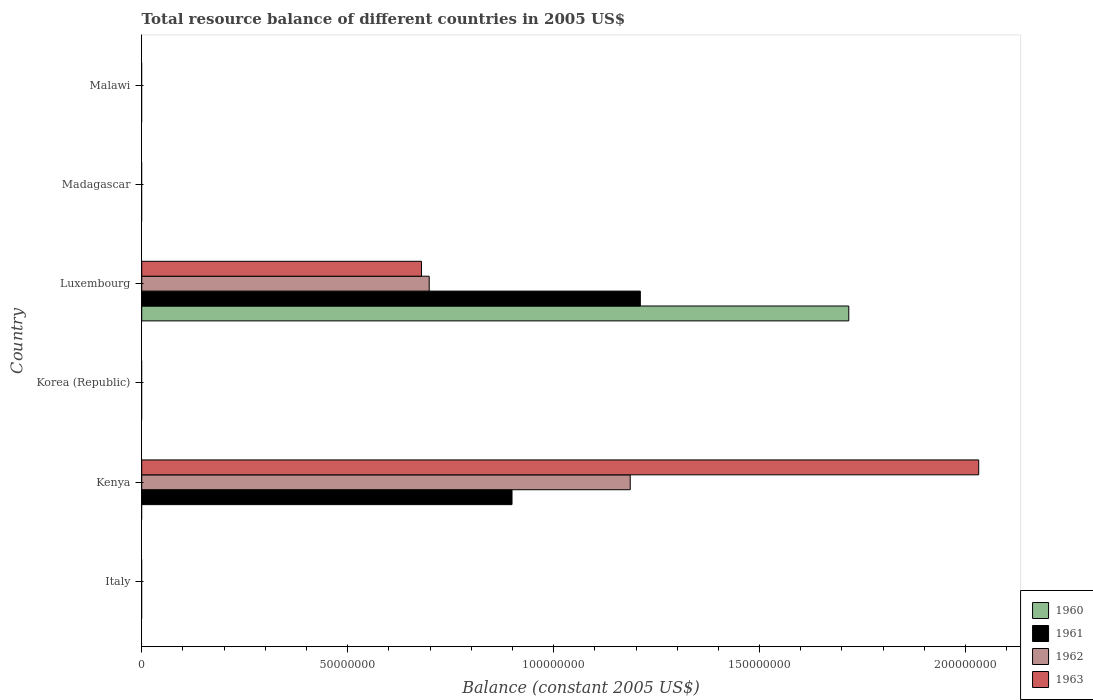Are the number of bars per tick equal to the number of legend labels?
Your answer should be very brief. No. How many bars are there on the 4th tick from the bottom?
Ensure brevity in your answer.  4. What is the total resource balance in 1962 in Korea (Republic)?
Provide a succinct answer. 0. Across all countries, what is the maximum total resource balance in 1963?
Make the answer very short. 2.03e+08. In which country was the total resource balance in 1960 maximum?
Your response must be concise. Luxembourg. What is the total total resource balance in 1963 in the graph?
Offer a terse response. 2.71e+08. What is the difference between the total resource balance in 1963 in Kenya and that in Luxembourg?
Your answer should be very brief. 1.35e+08. What is the difference between the total resource balance in 1962 in Kenya and the total resource balance in 1961 in Malawi?
Provide a succinct answer. 1.19e+08. What is the average total resource balance in 1961 per country?
Provide a succinct answer. 3.52e+07. What is the difference between the total resource balance in 1963 and total resource balance in 1960 in Luxembourg?
Keep it short and to the point. -1.04e+08. What is the difference between the highest and the lowest total resource balance in 1963?
Your answer should be very brief. 2.03e+08. Is it the case that in every country, the sum of the total resource balance in 1960 and total resource balance in 1962 is greater than the total resource balance in 1963?
Your answer should be compact. No. How many bars are there?
Offer a very short reply. 7. What is the difference between two consecutive major ticks on the X-axis?
Your response must be concise. 5.00e+07. Are the values on the major ticks of X-axis written in scientific E-notation?
Your answer should be very brief. No. Does the graph contain any zero values?
Offer a terse response. Yes. What is the title of the graph?
Provide a succinct answer. Total resource balance of different countries in 2005 US$. Does "2010" appear as one of the legend labels in the graph?
Offer a terse response. No. What is the label or title of the X-axis?
Offer a terse response. Balance (constant 2005 US$). What is the label or title of the Y-axis?
Offer a very short reply. Country. What is the Balance (constant 2005 US$) of 1960 in Italy?
Offer a very short reply. 0. What is the Balance (constant 2005 US$) in 1963 in Italy?
Make the answer very short. 0. What is the Balance (constant 2005 US$) of 1960 in Kenya?
Provide a short and direct response. 0. What is the Balance (constant 2005 US$) in 1961 in Kenya?
Offer a terse response. 8.99e+07. What is the Balance (constant 2005 US$) in 1962 in Kenya?
Offer a terse response. 1.19e+08. What is the Balance (constant 2005 US$) in 1963 in Kenya?
Offer a terse response. 2.03e+08. What is the Balance (constant 2005 US$) in 1962 in Korea (Republic)?
Ensure brevity in your answer.  0. What is the Balance (constant 2005 US$) of 1963 in Korea (Republic)?
Offer a very short reply. 0. What is the Balance (constant 2005 US$) of 1960 in Luxembourg?
Ensure brevity in your answer.  1.72e+08. What is the Balance (constant 2005 US$) in 1961 in Luxembourg?
Your answer should be compact. 1.21e+08. What is the Balance (constant 2005 US$) of 1962 in Luxembourg?
Your answer should be compact. 6.98e+07. What is the Balance (constant 2005 US$) of 1963 in Luxembourg?
Ensure brevity in your answer.  6.79e+07. What is the Balance (constant 2005 US$) in 1960 in Madagascar?
Keep it short and to the point. 0. What is the Balance (constant 2005 US$) of 1961 in Madagascar?
Your response must be concise. 0. What is the Balance (constant 2005 US$) of 1962 in Madagascar?
Offer a terse response. 0. What is the Balance (constant 2005 US$) of 1960 in Malawi?
Your answer should be very brief. 0. What is the Balance (constant 2005 US$) of 1961 in Malawi?
Offer a terse response. 0. What is the Balance (constant 2005 US$) of 1963 in Malawi?
Keep it short and to the point. 0. Across all countries, what is the maximum Balance (constant 2005 US$) in 1960?
Provide a short and direct response. 1.72e+08. Across all countries, what is the maximum Balance (constant 2005 US$) in 1961?
Offer a very short reply. 1.21e+08. Across all countries, what is the maximum Balance (constant 2005 US$) in 1962?
Offer a very short reply. 1.19e+08. Across all countries, what is the maximum Balance (constant 2005 US$) of 1963?
Make the answer very short. 2.03e+08. Across all countries, what is the minimum Balance (constant 2005 US$) in 1961?
Make the answer very short. 0. What is the total Balance (constant 2005 US$) in 1960 in the graph?
Offer a very short reply. 1.72e+08. What is the total Balance (constant 2005 US$) of 1961 in the graph?
Your response must be concise. 2.11e+08. What is the total Balance (constant 2005 US$) of 1962 in the graph?
Ensure brevity in your answer.  1.88e+08. What is the total Balance (constant 2005 US$) in 1963 in the graph?
Make the answer very short. 2.71e+08. What is the difference between the Balance (constant 2005 US$) of 1961 in Kenya and that in Luxembourg?
Provide a succinct answer. -3.11e+07. What is the difference between the Balance (constant 2005 US$) of 1962 in Kenya and that in Luxembourg?
Make the answer very short. 4.88e+07. What is the difference between the Balance (constant 2005 US$) in 1963 in Kenya and that in Luxembourg?
Provide a succinct answer. 1.35e+08. What is the difference between the Balance (constant 2005 US$) in 1961 in Kenya and the Balance (constant 2005 US$) in 1962 in Luxembourg?
Your answer should be very brief. 2.01e+07. What is the difference between the Balance (constant 2005 US$) in 1961 in Kenya and the Balance (constant 2005 US$) in 1963 in Luxembourg?
Your answer should be very brief. 2.20e+07. What is the difference between the Balance (constant 2005 US$) in 1962 in Kenya and the Balance (constant 2005 US$) in 1963 in Luxembourg?
Keep it short and to the point. 5.07e+07. What is the average Balance (constant 2005 US$) of 1960 per country?
Make the answer very short. 2.86e+07. What is the average Balance (constant 2005 US$) of 1961 per country?
Keep it short and to the point. 3.52e+07. What is the average Balance (constant 2005 US$) in 1962 per country?
Make the answer very short. 3.14e+07. What is the average Balance (constant 2005 US$) of 1963 per country?
Provide a succinct answer. 4.52e+07. What is the difference between the Balance (constant 2005 US$) of 1961 and Balance (constant 2005 US$) of 1962 in Kenya?
Your answer should be very brief. -2.87e+07. What is the difference between the Balance (constant 2005 US$) of 1961 and Balance (constant 2005 US$) of 1963 in Kenya?
Make the answer very short. -1.13e+08. What is the difference between the Balance (constant 2005 US$) of 1962 and Balance (constant 2005 US$) of 1963 in Kenya?
Keep it short and to the point. -8.46e+07. What is the difference between the Balance (constant 2005 US$) of 1960 and Balance (constant 2005 US$) of 1961 in Luxembourg?
Offer a terse response. 5.06e+07. What is the difference between the Balance (constant 2005 US$) of 1960 and Balance (constant 2005 US$) of 1962 in Luxembourg?
Provide a short and direct response. 1.02e+08. What is the difference between the Balance (constant 2005 US$) of 1960 and Balance (constant 2005 US$) of 1963 in Luxembourg?
Your answer should be compact. 1.04e+08. What is the difference between the Balance (constant 2005 US$) of 1961 and Balance (constant 2005 US$) of 1962 in Luxembourg?
Provide a short and direct response. 5.12e+07. What is the difference between the Balance (constant 2005 US$) in 1961 and Balance (constant 2005 US$) in 1963 in Luxembourg?
Provide a short and direct response. 5.31e+07. What is the difference between the Balance (constant 2005 US$) of 1962 and Balance (constant 2005 US$) of 1963 in Luxembourg?
Your answer should be compact. 1.88e+06. What is the ratio of the Balance (constant 2005 US$) of 1961 in Kenya to that in Luxembourg?
Your answer should be very brief. 0.74. What is the ratio of the Balance (constant 2005 US$) of 1962 in Kenya to that in Luxembourg?
Make the answer very short. 1.7. What is the ratio of the Balance (constant 2005 US$) in 1963 in Kenya to that in Luxembourg?
Keep it short and to the point. 2.99. What is the difference between the highest and the lowest Balance (constant 2005 US$) in 1960?
Provide a short and direct response. 1.72e+08. What is the difference between the highest and the lowest Balance (constant 2005 US$) in 1961?
Your response must be concise. 1.21e+08. What is the difference between the highest and the lowest Balance (constant 2005 US$) in 1962?
Offer a very short reply. 1.19e+08. What is the difference between the highest and the lowest Balance (constant 2005 US$) in 1963?
Your answer should be compact. 2.03e+08. 